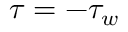<formula> <loc_0><loc_0><loc_500><loc_500>\tau = - \tau _ { w }</formula> 